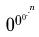Convert formula to latex. <formula><loc_0><loc_0><loc_500><loc_500>0 ^ { 0 ^ { 0 ^ { . ^ { . ^ { n } } } } }</formula> 